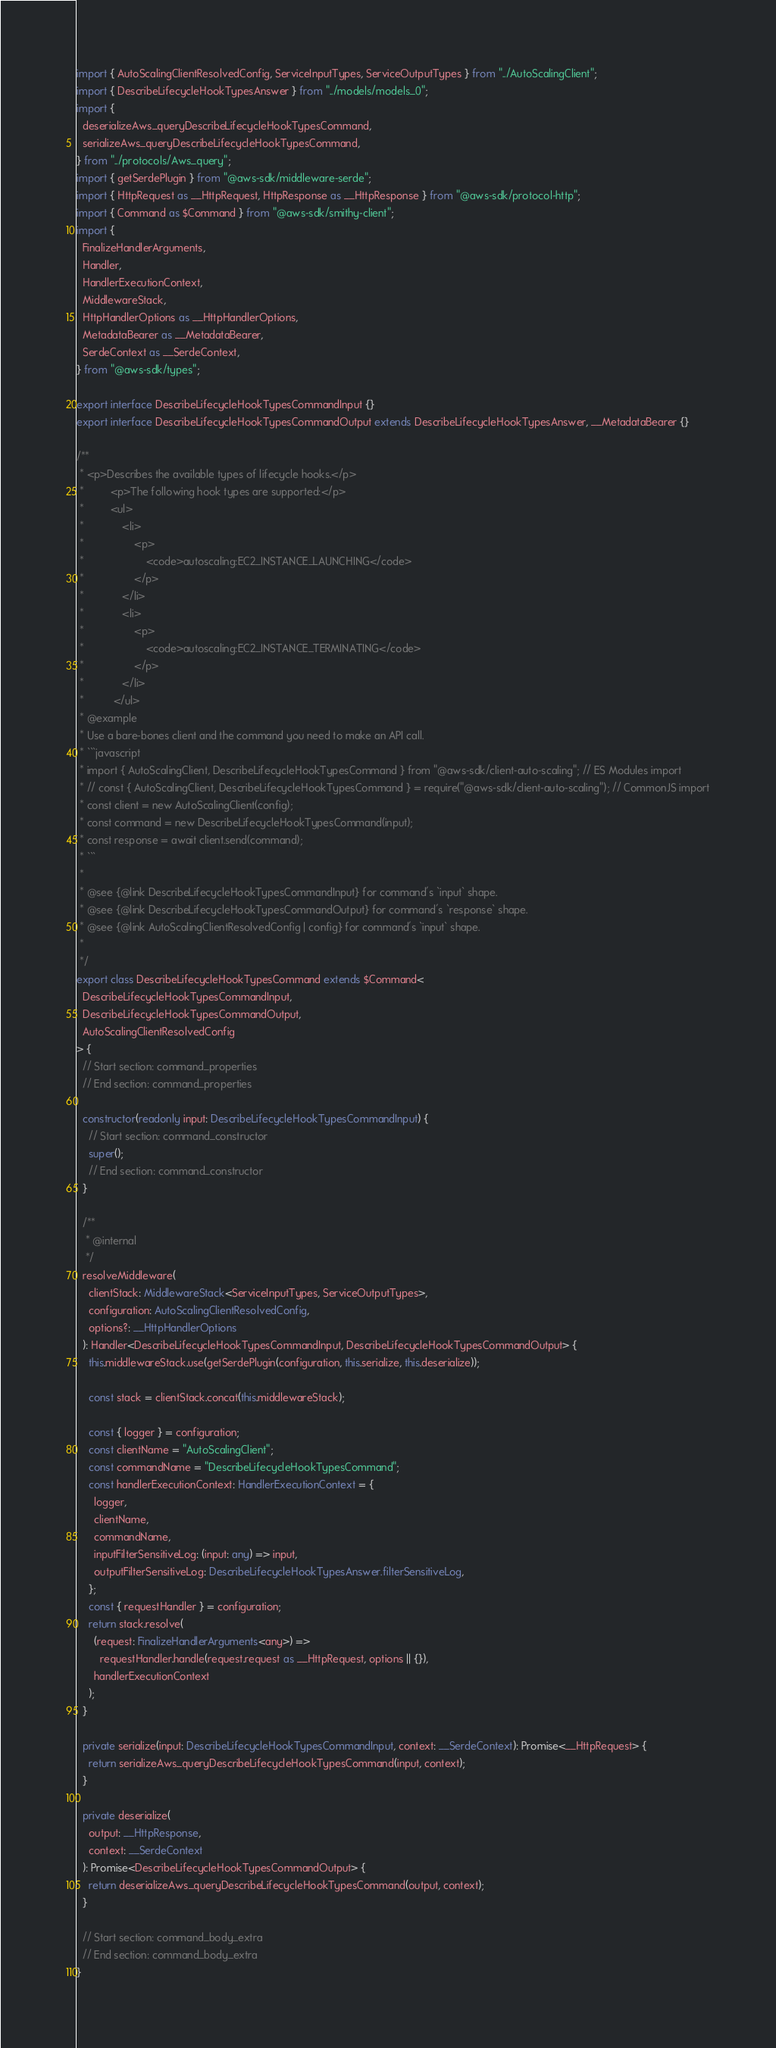<code> <loc_0><loc_0><loc_500><loc_500><_TypeScript_>import { AutoScalingClientResolvedConfig, ServiceInputTypes, ServiceOutputTypes } from "../AutoScalingClient";
import { DescribeLifecycleHookTypesAnswer } from "../models/models_0";
import {
  deserializeAws_queryDescribeLifecycleHookTypesCommand,
  serializeAws_queryDescribeLifecycleHookTypesCommand,
} from "../protocols/Aws_query";
import { getSerdePlugin } from "@aws-sdk/middleware-serde";
import { HttpRequest as __HttpRequest, HttpResponse as __HttpResponse } from "@aws-sdk/protocol-http";
import { Command as $Command } from "@aws-sdk/smithy-client";
import {
  FinalizeHandlerArguments,
  Handler,
  HandlerExecutionContext,
  MiddlewareStack,
  HttpHandlerOptions as __HttpHandlerOptions,
  MetadataBearer as __MetadataBearer,
  SerdeContext as __SerdeContext,
} from "@aws-sdk/types";

export interface DescribeLifecycleHookTypesCommandInput {}
export interface DescribeLifecycleHookTypesCommandOutput extends DescribeLifecycleHookTypesAnswer, __MetadataBearer {}

/**
 * <p>Describes the available types of lifecycle hooks.</p>
 *         <p>The following hook types are supported:</p>
 *         <ul>
 *             <li>
 *                 <p>
 *                     <code>autoscaling:EC2_INSTANCE_LAUNCHING</code>
 *                 </p>
 *             </li>
 *             <li>
 *                 <p>
 *                     <code>autoscaling:EC2_INSTANCE_TERMINATING</code>
 *                 </p>
 *             </li>
 *          </ul>
 * @example
 * Use a bare-bones client and the command you need to make an API call.
 * ```javascript
 * import { AutoScalingClient, DescribeLifecycleHookTypesCommand } from "@aws-sdk/client-auto-scaling"; // ES Modules import
 * // const { AutoScalingClient, DescribeLifecycleHookTypesCommand } = require("@aws-sdk/client-auto-scaling"); // CommonJS import
 * const client = new AutoScalingClient(config);
 * const command = new DescribeLifecycleHookTypesCommand(input);
 * const response = await client.send(command);
 * ```
 *
 * @see {@link DescribeLifecycleHookTypesCommandInput} for command's `input` shape.
 * @see {@link DescribeLifecycleHookTypesCommandOutput} for command's `response` shape.
 * @see {@link AutoScalingClientResolvedConfig | config} for command's `input` shape.
 *
 */
export class DescribeLifecycleHookTypesCommand extends $Command<
  DescribeLifecycleHookTypesCommandInput,
  DescribeLifecycleHookTypesCommandOutput,
  AutoScalingClientResolvedConfig
> {
  // Start section: command_properties
  // End section: command_properties

  constructor(readonly input: DescribeLifecycleHookTypesCommandInput) {
    // Start section: command_constructor
    super();
    // End section: command_constructor
  }

  /**
   * @internal
   */
  resolveMiddleware(
    clientStack: MiddlewareStack<ServiceInputTypes, ServiceOutputTypes>,
    configuration: AutoScalingClientResolvedConfig,
    options?: __HttpHandlerOptions
  ): Handler<DescribeLifecycleHookTypesCommandInput, DescribeLifecycleHookTypesCommandOutput> {
    this.middlewareStack.use(getSerdePlugin(configuration, this.serialize, this.deserialize));

    const stack = clientStack.concat(this.middlewareStack);

    const { logger } = configuration;
    const clientName = "AutoScalingClient";
    const commandName = "DescribeLifecycleHookTypesCommand";
    const handlerExecutionContext: HandlerExecutionContext = {
      logger,
      clientName,
      commandName,
      inputFilterSensitiveLog: (input: any) => input,
      outputFilterSensitiveLog: DescribeLifecycleHookTypesAnswer.filterSensitiveLog,
    };
    const { requestHandler } = configuration;
    return stack.resolve(
      (request: FinalizeHandlerArguments<any>) =>
        requestHandler.handle(request.request as __HttpRequest, options || {}),
      handlerExecutionContext
    );
  }

  private serialize(input: DescribeLifecycleHookTypesCommandInput, context: __SerdeContext): Promise<__HttpRequest> {
    return serializeAws_queryDescribeLifecycleHookTypesCommand(input, context);
  }

  private deserialize(
    output: __HttpResponse,
    context: __SerdeContext
  ): Promise<DescribeLifecycleHookTypesCommandOutput> {
    return deserializeAws_queryDescribeLifecycleHookTypesCommand(output, context);
  }

  // Start section: command_body_extra
  // End section: command_body_extra
}
</code> 